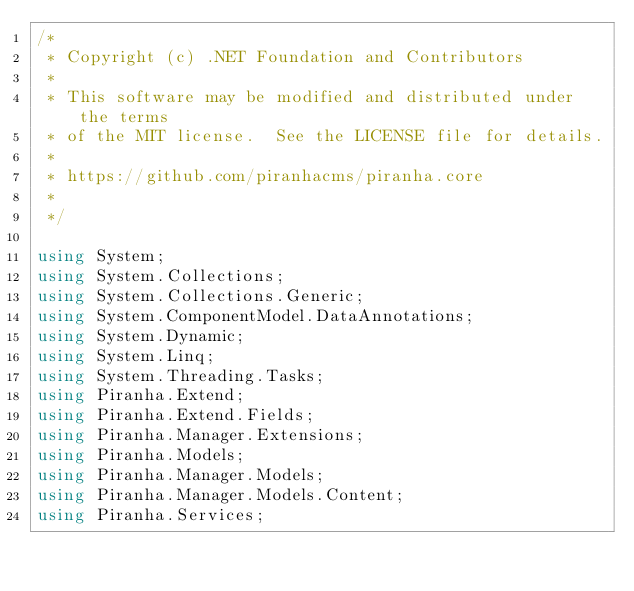Convert code to text. <code><loc_0><loc_0><loc_500><loc_500><_C#_>/*
 * Copyright (c) .NET Foundation and Contributors
 *
 * This software may be modified and distributed under the terms
 * of the MIT license.  See the LICENSE file for details.
 *
 * https://github.com/piranhacms/piranha.core
 *
 */

using System;
using System.Collections;
using System.Collections.Generic;
using System.ComponentModel.DataAnnotations;
using System.Dynamic;
using System.Linq;
using System.Threading.Tasks;
using Piranha.Extend;
using Piranha.Extend.Fields;
using Piranha.Manager.Extensions;
using Piranha.Models;
using Piranha.Manager.Models;
using Piranha.Manager.Models.Content;
using Piranha.Services;
</code> 